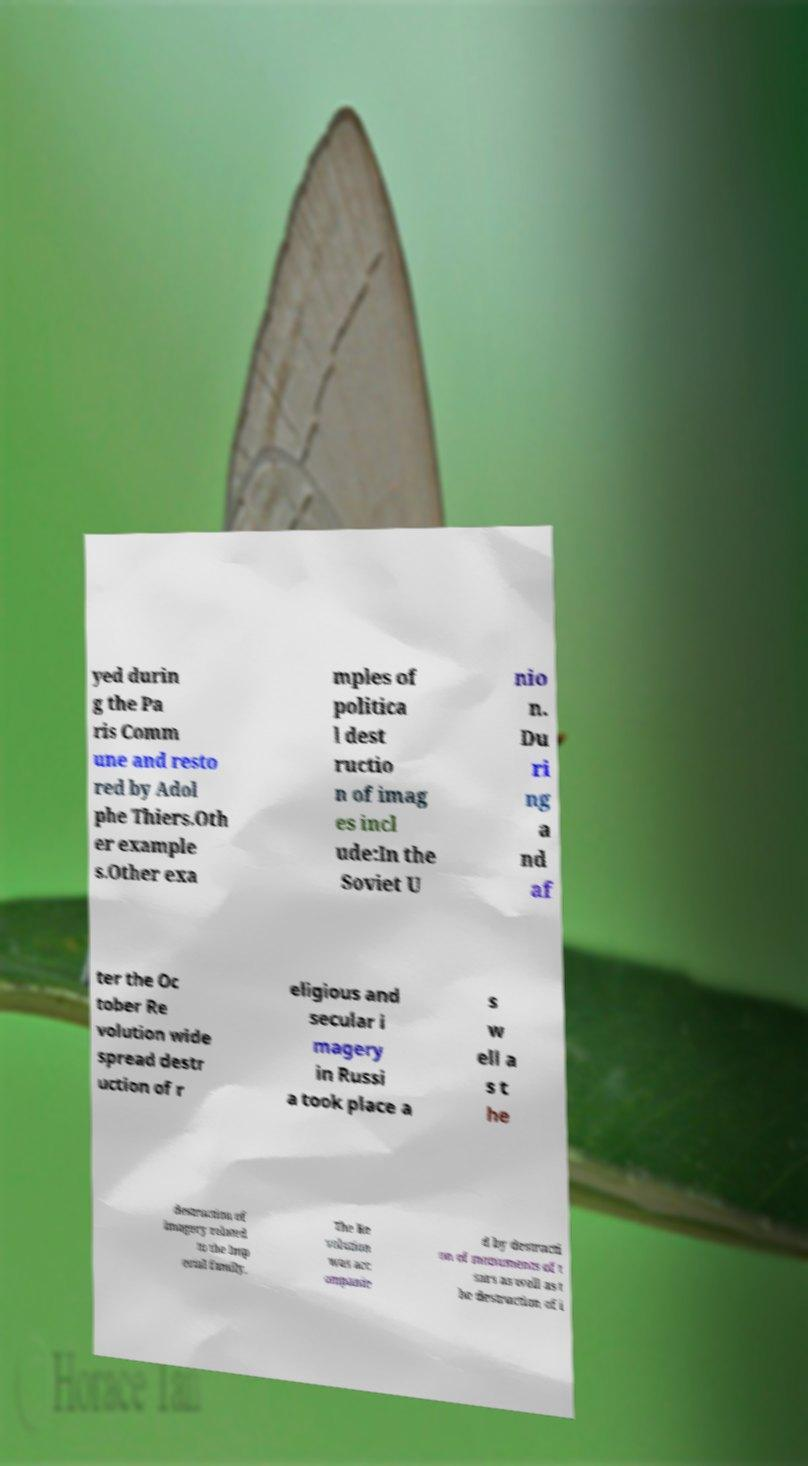Can you accurately transcribe the text from the provided image for me? yed durin g the Pa ris Comm une and resto red by Adol phe Thiers.Oth er example s.Other exa mples of politica l dest ructio n of imag es incl ude:In the Soviet U nio n. Du ri ng a nd af ter the Oc tober Re volution wide spread destr uction of r eligious and secular i magery in Russi a took place a s w ell a s t he destruction of imagery related to the Imp erial family. The Re volution was acc ompanie d by destructi on of monuments of t sars as well as t he destruction of i 